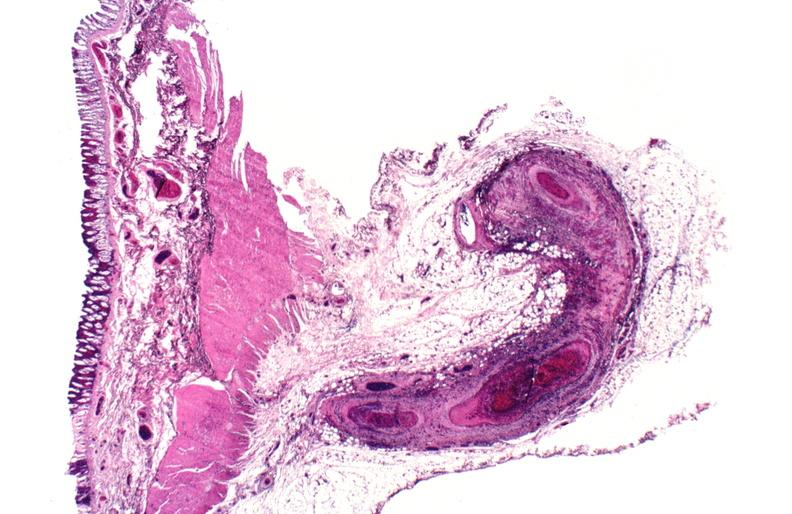s cardiovascular present?
Answer the question using a single word or phrase. Yes 